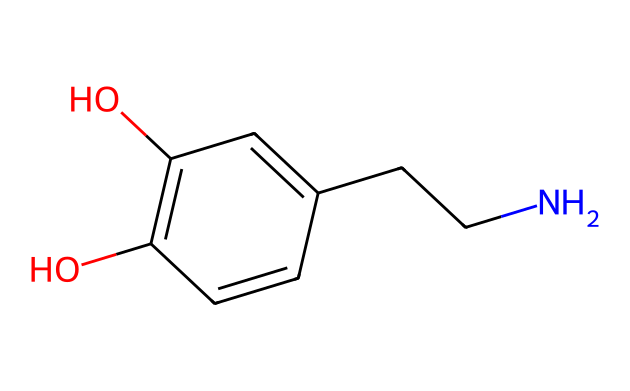What is the molecular formula of this compound? The molecule's composition can be determined from its structure by counting the atoms of each element. The provided SMILES indicates the presence of carbon (C), hydrogen (H), oxygen (O), and nitrogen (N) atoms. By analyzing the structure, we find there are 8 carbons, 11 hydrogens, 2 oxygens, and 1 nitrogen. Therefore, the molecular formula is C8H11NO2.
Answer: C8H11NO2 How many rings are present in the structure? A visual examination of the SMILES representation shows that this compound contains a six-membered aromatic ring (the benzene-like structure), which is the only ring present. Counting the visible elements of this structure confirms it as a single cycle.
Answer: 1 What type of functional groups are present in this molecule? Analyzing the molecular structure, we can identify two hydroxyl (-OH) groups attached to the benzene ring and one amine (-NH) group from the ethyl side chain. These indicate the presence of both phenolic and amine functional groups in the structure.
Answer: phenolic and amine What is the role of nitrogen in dopamine? The nitrogen atom in the structure contributes to the amine functional group, which is critical for the neurotransmitter's interaction with receptors in the brain. The presence of the nitrogen allows dopamine to act as a signaling molecule.
Answer: signaling How many total hydrogen atoms are connected to the aromatic carbon atoms? In the structure, the aromatic ring has five carbon atoms that are typically bonded to one hydrogen atom each; however, since two of these carbons are bonded to -OH groups, they do not have additional hydrogens. Thus, there are three hydrogen atoms directly connected to the aromatic carbons.
Answer: 3 What is the significance of the -OH groups in dopamine's function? The -OH groups in the dopamine structure are necessary for its solubility in water and play a critical role in the molecule's binding properties to dopamine receptors. They ensure that the molecule can effectively interact with target sites in the brain.
Answer: binding properties 